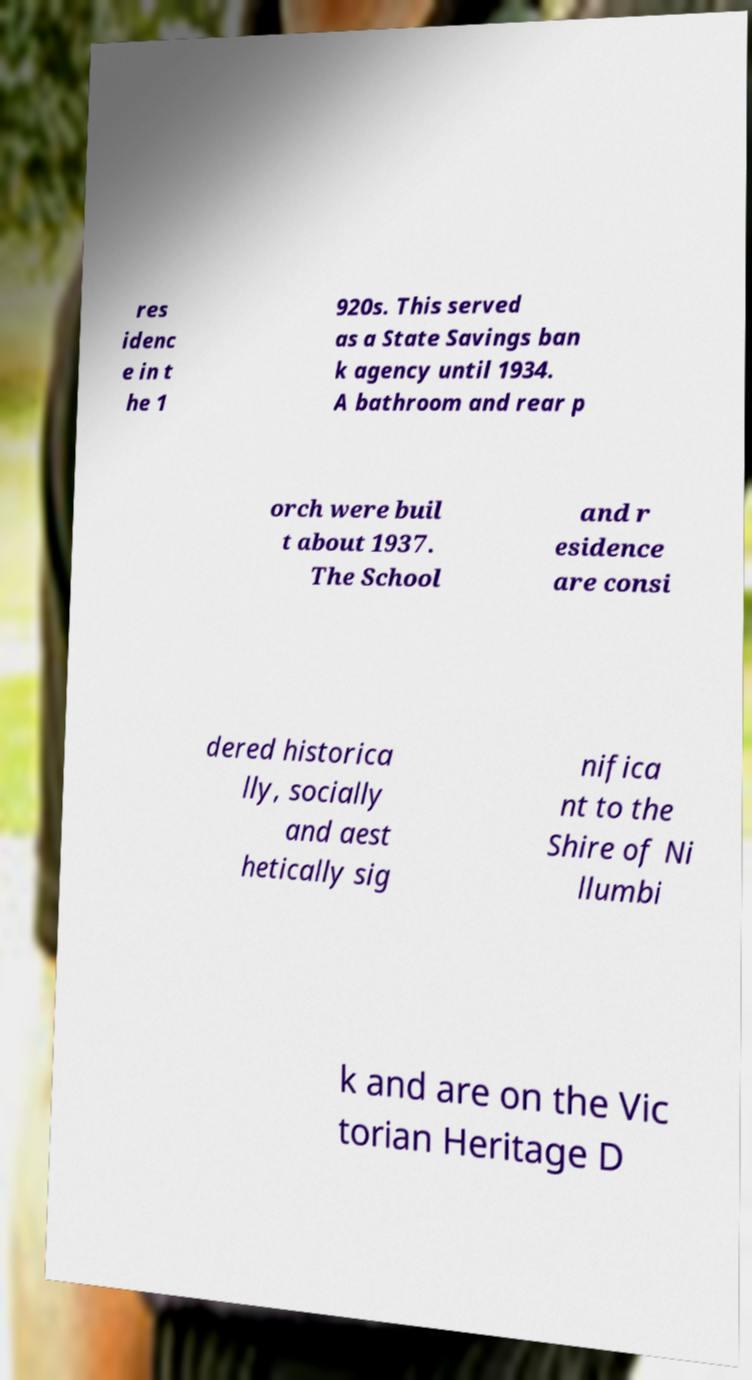Could you assist in decoding the text presented in this image and type it out clearly? res idenc e in t he 1 920s. This served as a State Savings ban k agency until 1934. A bathroom and rear p orch were buil t about 1937. The School and r esidence are consi dered historica lly, socially and aest hetically sig nifica nt to the Shire of Ni llumbi k and are on the Vic torian Heritage D 